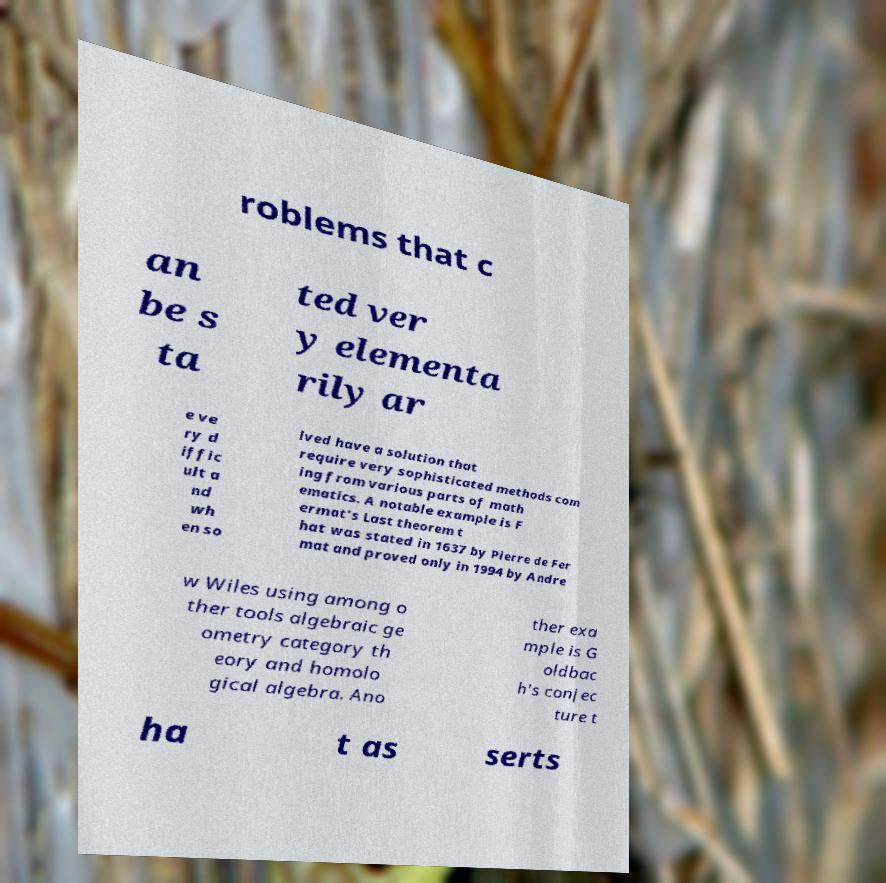I need the written content from this picture converted into text. Can you do that? roblems that c an be s ta ted ver y elementa rily ar e ve ry d iffic ult a nd wh en so lved have a solution that require very sophisticated methods com ing from various parts of math ematics. A notable example is F ermat's Last theorem t hat was stated in 1637 by Pierre de Fer mat and proved only in 1994 by Andre w Wiles using among o ther tools algebraic ge ometry category th eory and homolo gical algebra. Ano ther exa mple is G oldbac h's conjec ture t ha t as serts 